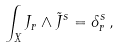<formula> <loc_0><loc_0><loc_500><loc_500>\int _ { X } J _ { r } \wedge \tilde { J } ^ { s } = \delta _ { r } ^ { s } \, ,</formula> 